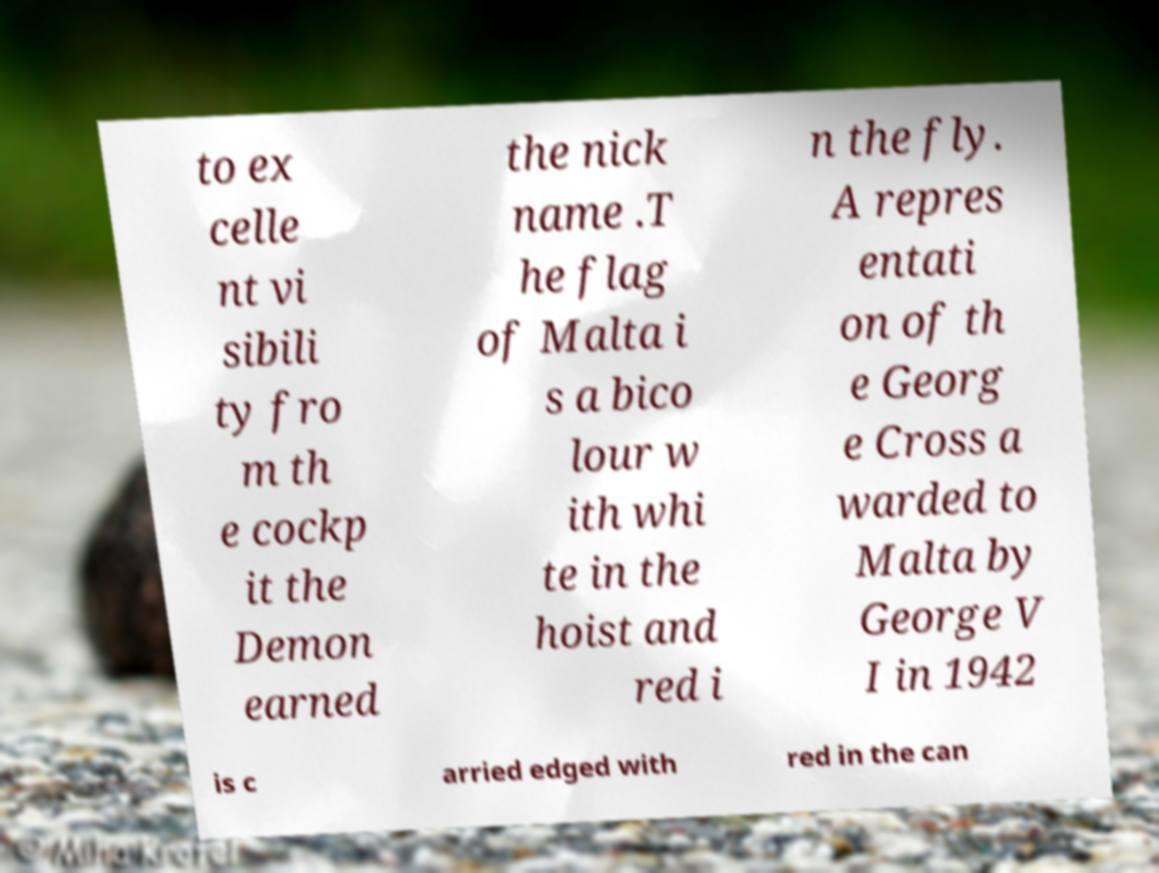Can you accurately transcribe the text from the provided image for me? to ex celle nt vi sibili ty fro m th e cockp it the Demon earned the nick name .T he flag of Malta i s a bico lour w ith whi te in the hoist and red i n the fly. A repres entati on of th e Georg e Cross a warded to Malta by George V I in 1942 is c arried edged with red in the can 